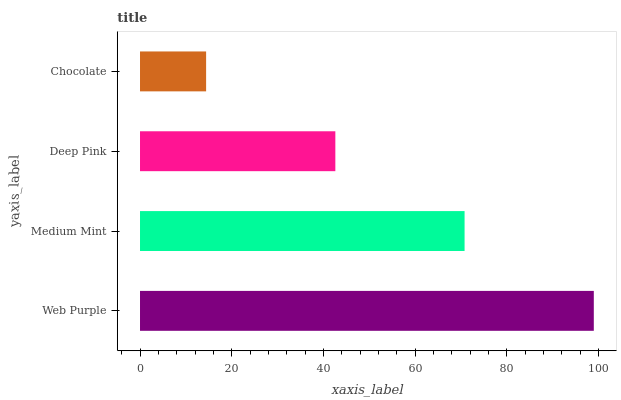Is Chocolate the minimum?
Answer yes or no. Yes. Is Web Purple the maximum?
Answer yes or no. Yes. Is Medium Mint the minimum?
Answer yes or no. No. Is Medium Mint the maximum?
Answer yes or no. No. Is Web Purple greater than Medium Mint?
Answer yes or no. Yes. Is Medium Mint less than Web Purple?
Answer yes or no. Yes. Is Medium Mint greater than Web Purple?
Answer yes or no. No. Is Web Purple less than Medium Mint?
Answer yes or no. No. Is Medium Mint the high median?
Answer yes or no. Yes. Is Deep Pink the low median?
Answer yes or no. Yes. Is Web Purple the high median?
Answer yes or no. No. Is Web Purple the low median?
Answer yes or no. No. 